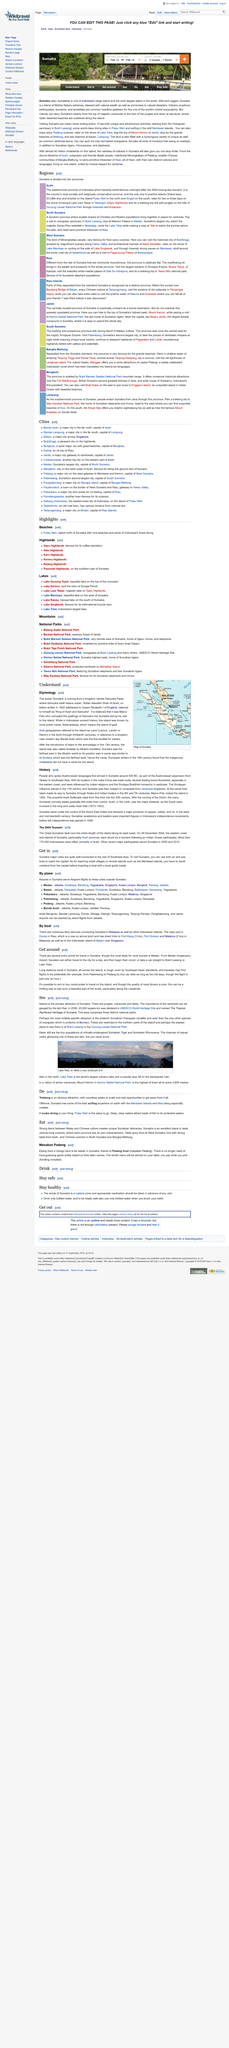Highlight a few significant elements in this photo. Sumatra was subject to conquests by Javanese kingdoms, which resulted in its eventual integration into the Javanese empire. Sumatra's history includes events such as its coming under the control of the Dutch East Indies and Marco Polo's visit in 1292, which are both true. The Aceh War occurred between 1873 and 1903. 